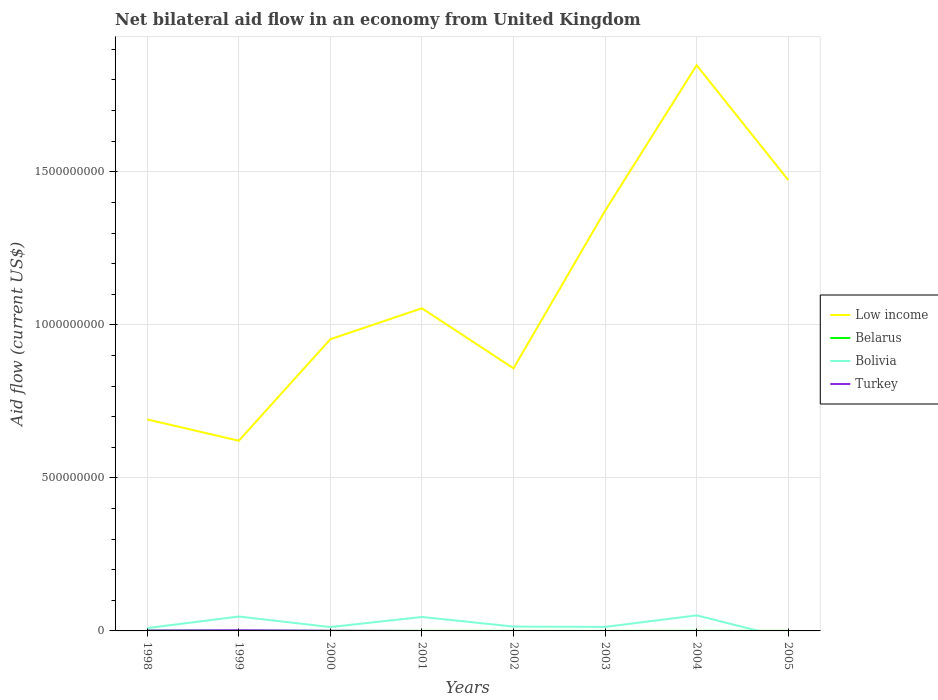Is the number of lines equal to the number of legend labels?
Ensure brevity in your answer.  No. Across all years, what is the maximum net bilateral aid flow in Belarus?
Your answer should be very brief. 7.00e+04. What is the total net bilateral aid flow in Belarus in the graph?
Your answer should be very brief. 6.70e+05. What is the difference between the highest and the second highest net bilateral aid flow in Low income?
Offer a terse response. 1.23e+09. What is the difference between the highest and the lowest net bilateral aid flow in Bolivia?
Your answer should be compact. 3. Is the net bilateral aid flow in Bolivia strictly greater than the net bilateral aid flow in Belarus over the years?
Keep it short and to the point. No. What is the difference between two consecutive major ticks on the Y-axis?
Your answer should be very brief. 5.00e+08. Are the values on the major ticks of Y-axis written in scientific E-notation?
Offer a terse response. No. Does the graph contain any zero values?
Make the answer very short. Yes. Does the graph contain grids?
Your answer should be very brief. Yes. Where does the legend appear in the graph?
Provide a succinct answer. Center right. What is the title of the graph?
Keep it short and to the point. Net bilateral aid flow in an economy from United Kingdom. Does "Romania" appear as one of the legend labels in the graph?
Your answer should be very brief. No. What is the label or title of the X-axis?
Offer a terse response. Years. What is the Aid flow (current US$) in Low income in 1998?
Your answer should be compact. 6.91e+08. What is the Aid flow (current US$) of Bolivia in 1998?
Your response must be concise. 9.27e+06. What is the Aid flow (current US$) of Turkey in 1998?
Make the answer very short. 1.27e+06. What is the Aid flow (current US$) in Low income in 1999?
Make the answer very short. 6.21e+08. What is the Aid flow (current US$) in Belarus in 1999?
Ensure brevity in your answer.  5.80e+05. What is the Aid flow (current US$) in Bolivia in 1999?
Your answer should be compact. 4.70e+07. What is the Aid flow (current US$) of Turkey in 1999?
Offer a very short reply. 2.30e+06. What is the Aid flow (current US$) of Low income in 2000?
Make the answer very short. 9.53e+08. What is the Aid flow (current US$) of Belarus in 2000?
Offer a terse response. 2.10e+05. What is the Aid flow (current US$) in Bolivia in 2000?
Provide a short and direct response. 1.26e+07. What is the Aid flow (current US$) of Turkey in 2000?
Your response must be concise. 5.40e+05. What is the Aid flow (current US$) in Low income in 2001?
Your answer should be compact. 1.05e+09. What is the Aid flow (current US$) in Bolivia in 2001?
Make the answer very short. 4.56e+07. What is the Aid flow (current US$) in Low income in 2002?
Offer a very short reply. 8.58e+08. What is the Aid flow (current US$) in Bolivia in 2002?
Offer a terse response. 1.42e+07. What is the Aid flow (current US$) of Turkey in 2002?
Offer a terse response. 0. What is the Aid flow (current US$) of Low income in 2003?
Ensure brevity in your answer.  1.37e+09. What is the Aid flow (current US$) of Bolivia in 2003?
Make the answer very short. 1.31e+07. What is the Aid flow (current US$) in Turkey in 2003?
Make the answer very short. 0. What is the Aid flow (current US$) of Low income in 2004?
Ensure brevity in your answer.  1.85e+09. What is the Aid flow (current US$) in Bolivia in 2004?
Offer a terse response. 5.08e+07. What is the Aid flow (current US$) of Low income in 2005?
Your answer should be very brief. 1.47e+09. What is the Aid flow (current US$) of Belarus in 2005?
Give a very brief answer. 1.10e+05. What is the Aid flow (current US$) in Bolivia in 2005?
Your response must be concise. 0. Across all years, what is the maximum Aid flow (current US$) in Low income?
Ensure brevity in your answer.  1.85e+09. Across all years, what is the maximum Aid flow (current US$) of Bolivia?
Give a very brief answer. 5.08e+07. Across all years, what is the maximum Aid flow (current US$) of Turkey?
Provide a succinct answer. 2.30e+06. Across all years, what is the minimum Aid flow (current US$) in Low income?
Offer a very short reply. 6.21e+08. Across all years, what is the minimum Aid flow (current US$) in Belarus?
Keep it short and to the point. 7.00e+04. Across all years, what is the minimum Aid flow (current US$) of Bolivia?
Offer a very short reply. 0. Across all years, what is the minimum Aid flow (current US$) in Turkey?
Offer a very short reply. 0. What is the total Aid flow (current US$) of Low income in the graph?
Offer a terse response. 8.87e+09. What is the total Aid flow (current US$) in Belarus in the graph?
Offer a very short reply. 2.19e+06. What is the total Aid flow (current US$) in Bolivia in the graph?
Offer a terse response. 1.93e+08. What is the total Aid flow (current US$) of Turkey in the graph?
Make the answer very short. 4.11e+06. What is the difference between the Aid flow (current US$) of Low income in 1998 and that in 1999?
Make the answer very short. 6.96e+07. What is the difference between the Aid flow (current US$) in Bolivia in 1998 and that in 1999?
Your response must be concise. -3.78e+07. What is the difference between the Aid flow (current US$) of Turkey in 1998 and that in 1999?
Give a very brief answer. -1.03e+06. What is the difference between the Aid flow (current US$) of Low income in 1998 and that in 2000?
Offer a very short reply. -2.62e+08. What is the difference between the Aid flow (current US$) in Belarus in 1998 and that in 2000?
Ensure brevity in your answer.  5.90e+05. What is the difference between the Aid flow (current US$) in Bolivia in 1998 and that in 2000?
Provide a succinct answer. -3.32e+06. What is the difference between the Aid flow (current US$) of Turkey in 1998 and that in 2000?
Your answer should be compact. 7.30e+05. What is the difference between the Aid flow (current US$) of Low income in 1998 and that in 2001?
Your answer should be very brief. -3.63e+08. What is the difference between the Aid flow (current US$) of Belarus in 1998 and that in 2001?
Provide a succinct answer. 6.70e+05. What is the difference between the Aid flow (current US$) in Bolivia in 1998 and that in 2001?
Your response must be concise. -3.63e+07. What is the difference between the Aid flow (current US$) in Low income in 1998 and that in 2002?
Your answer should be very brief. -1.67e+08. What is the difference between the Aid flow (current US$) in Belarus in 1998 and that in 2002?
Ensure brevity in your answer.  7.10e+05. What is the difference between the Aid flow (current US$) of Bolivia in 1998 and that in 2002?
Provide a succinct answer. -4.92e+06. What is the difference between the Aid flow (current US$) of Low income in 1998 and that in 2003?
Offer a terse response. -6.82e+08. What is the difference between the Aid flow (current US$) in Belarus in 1998 and that in 2003?
Keep it short and to the point. 7.30e+05. What is the difference between the Aid flow (current US$) of Bolivia in 1998 and that in 2003?
Provide a short and direct response. -3.83e+06. What is the difference between the Aid flow (current US$) in Low income in 1998 and that in 2004?
Offer a terse response. -1.16e+09. What is the difference between the Aid flow (current US$) of Bolivia in 1998 and that in 2004?
Ensure brevity in your answer.  -4.16e+07. What is the difference between the Aid flow (current US$) of Low income in 1998 and that in 2005?
Provide a succinct answer. -7.82e+08. What is the difference between the Aid flow (current US$) in Belarus in 1998 and that in 2005?
Keep it short and to the point. 6.90e+05. What is the difference between the Aid flow (current US$) of Low income in 1999 and that in 2000?
Provide a succinct answer. -3.32e+08. What is the difference between the Aid flow (current US$) in Belarus in 1999 and that in 2000?
Keep it short and to the point. 3.70e+05. What is the difference between the Aid flow (current US$) of Bolivia in 1999 and that in 2000?
Give a very brief answer. 3.45e+07. What is the difference between the Aid flow (current US$) of Turkey in 1999 and that in 2000?
Make the answer very short. 1.76e+06. What is the difference between the Aid flow (current US$) in Low income in 1999 and that in 2001?
Ensure brevity in your answer.  -4.33e+08. What is the difference between the Aid flow (current US$) in Belarus in 1999 and that in 2001?
Provide a succinct answer. 4.50e+05. What is the difference between the Aid flow (current US$) of Bolivia in 1999 and that in 2001?
Offer a very short reply. 1.47e+06. What is the difference between the Aid flow (current US$) in Low income in 1999 and that in 2002?
Ensure brevity in your answer.  -2.37e+08. What is the difference between the Aid flow (current US$) in Belarus in 1999 and that in 2002?
Offer a terse response. 4.90e+05. What is the difference between the Aid flow (current US$) in Bolivia in 1999 and that in 2002?
Offer a terse response. 3.29e+07. What is the difference between the Aid flow (current US$) in Low income in 1999 and that in 2003?
Provide a succinct answer. -7.51e+08. What is the difference between the Aid flow (current US$) of Belarus in 1999 and that in 2003?
Ensure brevity in your answer.  5.10e+05. What is the difference between the Aid flow (current US$) of Bolivia in 1999 and that in 2003?
Your answer should be compact. 3.40e+07. What is the difference between the Aid flow (current US$) in Low income in 1999 and that in 2004?
Keep it short and to the point. -1.23e+09. What is the difference between the Aid flow (current US$) of Belarus in 1999 and that in 2004?
Offer a very short reply. 3.80e+05. What is the difference between the Aid flow (current US$) in Bolivia in 1999 and that in 2004?
Give a very brief answer. -3.78e+06. What is the difference between the Aid flow (current US$) of Low income in 1999 and that in 2005?
Your response must be concise. -8.52e+08. What is the difference between the Aid flow (current US$) in Belarus in 1999 and that in 2005?
Provide a short and direct response. 4.70e+05. What is the difference between the Aid flow (current US$) in Low income in 2000 and that in 2001?
Provide a short and direct response. -1.01e+08. What is the difference between the Aid flow (current US$) of Belarus in 2000 and that in 2001?
Make the answer very short. 8.00e+04. What is the difference between the Aid flow (current US$) of Bolivia in 2000 and that in 2001?
Make the answer very short. -3.30e+07. What is the difference between the Aid flow (current US$) in Low income in 2000 and that in 2002?
Make the answer very short. 9.52e+07. What is the difference between the Aid flow (current US$) in Bolivia in 2000 and that in 2002?
Give a very brief answer. -1.60e+06. What is the difference between the Aid flow (current US$) of Low income in 2000 and that in 2003?
Your answer should be very brief. -4.20e+08. What is the difference between the Aid flow (current US$) in Bolivia in 2000 and that in 2003?
Ensure brevity in your answer.  -5.10e+05. What is the difference between the Aid flow (current US$) in Low income in 2000 and that in 2004?
Provide a succinct answer. -8.95e+08. What is the difference between the Aid flow (current US$) in Belarus in 2000 and that in 2004?
Provide a succinct answer. 10000. What is the difference between the Aid flow (current US$) of Bolivia in 2000 and that in 2004?
Ensure brevity in your answer.  -3.82e+07. What is the difference between the Aid flow (current US$) in Low income in 2000 and that in 2005?
Provide a succinct answer. -5.20e+08. What is the difference between the Aid flow (current US$) of Belarus in 2000 and that in 2005?
Provide a short and direct response. 1.00e+05. What is the difference between the Aid flow (current US$) in Low income in 2001 and that in 2002?
Your answer should be compact. 1.96e+08. What is the difference between the Aid flow (current US$) of Bolivia in 2001 and that in 2002?
Give a very brief answer. 3.14e+07. What is the difference between the Aid flow (current US$) in Low income in 2001 and that in 2003?
Provide a short and direct response. -3.19e+08. What is the difference between the Aid flow (current US$) in Belarus in 2001 and that in 2003?
Give a very brief answer. 6.00e+04. What is the difference between the Aid flow (current US$) in Bolivia in 2001 and that in 2003?
Your response must be concise. 3.25e+07. What is the difference between the Aid flow (current US$) of Low income in 2001 and that in 2004?
Offer a very short reply. -7.94e+08. What is the difference between the Aid flow (current US$) in Bolivia in 2001 and that in 2004?
Offer a terse response. -5.25e+06. What is the difference between the Aid flow (current US$) in Low income in 2001 and that in 2005?
Keep it short and to the point. -4.19e+08. What is the difference between the Aid flow (current US$) in Low income in 2002 and that in 2003?
Keep it short and to the point. -5.15e+08. What is the difference between the Aid flow (current US$) in Belarus in 2002 and that in 2003?
Ensure brevity in your answer.  2.00e+04. What is the difference between the Aid flow (current US$) of Bolivia in 2002 and that in 2003?
Keep it short and to the point. 1.09e+06. What is the difference between the Aid flow (current US$) of Low income in 2002 and that in 2004?
Make the answer very short. -9.90e+08. What is the difference between the Aid flow (current US$) of Bolivia in 2002 and that in 2004?
Your answer should be compact. -3.66e+07. What is the difference between the Aid flow (current US$) in Low income in 2002 and that in 2005?
Your answer should be compact. -6.15e+08. What is the difference between the Aid flow (current US$) in Belarus in 2002 and that in 2005?
Provide a short and direct response. -2.00e+04. What is the difference between the Aid flow (current US$) in Low income in 2003 and that in 2004?
Provide a short and direct response. -4.76e+08. What is the difference between the Aid flow (current US$) of Bolivia in 2003 and that in 2004?
Keep it short and to the point. -3.77e+07. What is the difference between the Aid flow (current US$) of Low income in 2003 and that in 2005?
Keep it short and to the point. -1.01e+08. What is the difference between the Aid flow (current US$) in Low income in 2004 and that in 2005?
Your response must be concise. 3.75e+08. What is the difference between the Aid flow (current US$) of Low income in 1998 and the Aid flow (current US$) of Belarus in 1999?
Your answer should be very brief. 6.90e+08. What is the difference between the Aid flow (current US$) in Low income in 1998 and the Aid flow (current US$) in Bolivia in 1999?
Offer a very short reply. 6.44e+08. What is the difference between the Aid flow (current US$) of Low income in 1998 and the Aid flow (current US$) of Turkey in 1999?
Provide a succinct answer. 6.89e+08. What is the difference between the Aid flow (current US$) in Belarus in 1998 and the Aid flow (current US$) in Bolivia in 1999?
Keep it short and to the point. -4.62e+07. What is the difference between the Aid flow (current US$) of Belarus in 1998 and the Aid flow (current US$) of Turkey in 1999?
Give a very brief answer. -1.50e+06. What is the difference between the Aid flow (current US$) of Bolivia in 1998 and the Aid flow (current US$) of Turkey in 1999?
Your response must be concise. 6.97e+06. What is the difference between the Aid flow (current US$) in Low income in 1998 and the Aid flow (current US$) in Belarus in 2000?
Your response must be concise. 6.91e+08. What is the difference between the Aid flow (current US$) of Low income in 1998 and the Aid flow (current US$) of Bolivia in 2000?
Your response must be concise. 6.78e+08. What is the difference between the Aid flow (current US$) of Low income in 1998 and the Aid flow (current US$) of Turkey in 2000?
Ensure brevity in your answer.  6.90e+08. What is the difference between the Aid flow (current US$) in Belarus in 1998 and the Aid flow (current US$) in Bolivia in 2000?
Your answer should be very brief. -1.18e+07. What is the difference between the Aid flow (current US$) in Belarus in 1998 and the Aid flow (current US$) in Turkey in 2000?
Make the answer very short. 2.60e+05. What is the difference between the Aid flow (current US$) of Bolivia in 1998 and the Aid flow (current US$) of Turkey in 2000?
Your answer should be compact. 8.73e+06. What is the difference between the Aid flow (current US$) in Low income in 1998 and the Aid flow (current US$) in Belarus in 2001?
Offer a terse response. 6.91e+08. What is the difference between the Aid flow (current US$) of Low income in 1998 and the Aid flow (current US$) of Bolivia in 2001?
Your answer should be compact. 6.45e+08. What is the difference between the Aid flow (current US$) of Belarus in 1998 and the Aid flow (current US$) of Bolivia in 2001?
Offer a terse response. -4.48e+07. What is the difference between the Aid flow (current US$) of Low income in 1998 and the Aid flow (current US$) of Belarus in 2002?
Provide a succinct answer. 6.91e+08. What is the difference between the Aid flow (current US$) in Low income in 1998 and the Aid flow (current US$) in Bolivia in 2002?
Your answer should be compact. 6.77e+08. What is the difference between the Aid flow (current US$) of Belarus in 1998 and the Aid flow (current US$) of Bolivia in 2002?
Your answer should be compact. -1.34e+07. What is the difference between the Aid flow (current US$) in Low income in 1998 and the Aid flow (current US$) in Belarus in 2003?
Ensure brevity in your answer.  6.91e+08. What is the difference between the Aid flow (current US$) of Low income in 1998 and the Aid flow (current US$) of Bolivia in 2003?
Offer a terse response. 6.78e+08. What is the difference between the Aid flow (current US$) of Belarus in 1998 and the Aid flow (current US$) of Bolivia in 2003?
Offer a terse response. -1.23e+07. What is the difference between the Aid flow (current US$) of Low income in 1998 and the Aid flow (current US$) of Belarus in 2004?
Your answer should be very brief. 6.91e+08. What is the difference between the Aid flow (current US$) of Low income in 1998 and the Aid flow (current US$) of Bolivia in 2004?
Your response must be concise. 6.40e+08. What is the difference between the Aid flow (current US$) of Belarus in 1998 and the Aid flow (current US$) of Bolivia in 2004?
Your answer should be compact. -5.00e+07. What is the difference between the Aid flow (current US$) of Low income in 1998 and the Aid flow (current US$) of Belarus in 2005?
Provide a succinct answer. 6.91e+08. What is the difference between the Aid flow (current US$) in Low income in 1999 and the Aid flow (current US$) in Belarus in 2000?
Ensure brevity in your answer.  6.21e+08. What is the difference between the Aid flow (current US$) of Low income in 1999 and the Aid flow (current US$) of Bolivia in 2000?
Offer a very short reply. 6.09e+08. What is the difference between the Aid flow (current US$) of Low income in 1999 and the Aid flow (current US$) of Turkey in 2000?
Keep it short and to the point. 6.21e+08. What is the difference between the Aid flow (current US$) in Belarus in 1999 and the Aid flow (current US$) in Bolivia in 2000?
Keep it short and to the point. -1.20e+07. What is the difference between the Aid flow (current US$) of Belarus in 1999 and the Aid flow (current US$) of Turkey in 2000?
Your answer should be very brief. 4.00e+04. What is the difference between the Aid flow (current US$) in Bolivia in 1999 and the Aid flow (current US$) in Turkey in 2000?
Provide a short and direct response. 4.65e+07. What is the difference between the Aid flow (current US$) in Low income in 1999 and the Aid flow (current US$) in Belarus in 2001?
Ensure brevity in your answer.  6.21e+08. What is the difference between the Aid flow (current US$) in Low income in 1999 and the Aid flow (current US$) in Bolivia in 2001?
Offer a very short reply. 5.76e+08. What is the difference between the Aid flow (current US$) of Belarus in 1999 and the Aid flow (current US$) of Bolivia in 2001?
Give a very brief answer. -4.50e+07. What is the difference between the Aid flow (current US$) in Low income in 1999 and the Aid flow (current US$) in Belarus in 2002?
Keep it short and to the point. 6.21e+08. What is the difference between the Aid flow (current US$) in Low income in 1999 and the Aid flow (current US$) in Bolivia in 2002?
Your response must be concise. 6.07e+08. What is the difference between the Aid flow (current US$) of Belarus in 1999 and the Aid flow (current US$) of Bolivia in 2002?
Make the answer very short. -1.36e+07. What is the difference between the Aid flow (current US$) of Low income in 1999 and the Aid flow (current US$) of Belarus in 2003?
Make the answer very short. 6.21e+08. What is the difference between the Aid flow (current US$) in Low income in 1999 and the Aid flow (current US$) in Bolivia in 2003?
Give a very brief answer. 6.08e+08. What is the difference between the Aid flow (current US$) in Belarus in 1999 and the Aid flow (current US$) in Bolivia in 2003?
Ensure brevity in your answer.  -1.25e+07. What is the difference between the Aid flow (current US$) of Low income in 1999 and the Aid flow (current US$) of Belarus in 2004?
Keep it short and to the point. 6.21e+08. What is the difference between the Aid flow (current US$) of Low income in 1999 and the Aid flow (current US$) of Bolivia in 2004?
Your answer should be very brief. 5.71e+08. What is the difference between the Aid flow (current US$) in Belarus in 1999 and the Aid flow (current US$) in Bolivia in 2004?
Offer a terse response. -5.02e+07. What is the difference between the Aid flow (current US$) in Low income in 1999 and the Aid flow (current US$) in Belarus in 2005?
Make the answer very short. 6.21e+08. What is the difference between the Aid flow (current US$) in Low income in 2000 and the Aid flow (current US$) in Belarus in 2001?
Give a very brief answer. 9.53e+08. What is the difference between the Aid flow (current US$) of Low income in 2000 and the Aid flow (current US$) of Bolivia in 2001?
Your answer should be compact. 9.08e+08. What is the difference between the Aid flow (current US$) in Belarus in 2000 and the Aid flow (current US$) in Bolivia in 2001?
Offer a very short reply. -4.54e+07. What is the difference between the Aid flow (current US$) of Low income in 2000 and the Aid flow (current US$) of Belarus in 2002?
Provide a short and direct response. 9.53e+08. What is the difference between the Aid flow (current US$) in Low income in 2000 and the Aid flow (current US$) in Bolivia in 2002?
Keep it short and to the point. 9.39e+08. What is the difference between the Aid flow (current US$) in Belarus in 2000 and the Aid flow (current US$) in Bolivia in 2002?
Your answer should be compact. -1.40e+07. What is the difference between the Aid flow (current US$) in Low income in 2000 and the Aid flow (current US$) in Belarus in 2003?
Make the answer very short. 9.53e+08. What is the difference between the Aid flow (current US$) in Low income in 2000 and the Aid flow (current US$) in Bolivia in 2003?
Make the answer very short. 9.40e+08. What is the difference between the Aid flow (current US$) in Belarus in 2000 and the Aid flow (current US$) in Bolivia in 2003?
Give a very brief answer. -1.29e+07. What is the difference between the Aid flow (current US$) of Low income in 2000 and the Aid flow (current US$) of Belarus in 2004?
Provide a short and direct response. 9.53e+08. What is the difference between the Aid flow (current US$) in Low income in 2000 and the Aid flow (current US$) in Bolivia in 2004?
Your response must be concise. 9.02e+08. What is the difference between the Aid flow (current US$) of Belarus in 2000 and the Aid flow (current US$) of Bolivia in 2004?
Provide a succinct answer. -5.06e+07. What is the difference between the Aid flow (current US$) of Low income in 2000 and the Aid flow (current US$) of Belarus in 2005?
Give a very brief answer. 9.53e+08. What is the difference between the Aid flow (current US$) in Low income in 2001 and the Aid flow (current US$) in Belarus in 2002?
Your answer should be very brief. 1.05e+09. What is the difference between the Aid flow (current US$) in Low income in 2001 and the Aid flow (current US$) in Bolivia in 2002?
Make the answer very short. 1.04e+09. What is the difference between the Aid flow (current US$) of Belarus in 2001 and the Aid flow (current US$) of Bolivia in 2002?
Your response must be concise. -1.41e+07. What is the difference between the Aid flow (current US$) in Low income in 2001 and the Aid flow (current US$) in Belarus in 2003?
Provide a short and direct response. 1.05e+09. What is the difference between the Aid flow (current US$) of Low income in 2001 and the Aid flow (current US$) of Bolivia in 2003?
Your answer should be compact. 1.04e+09. What is the difference between the Aid flow (current US$) in Belarus in 2001 and the Aid flow (current US$) in Bolivia in 2003?
Offer a terse response. -1.30e+07. What is the difference between the Aid flow (current US$) of Low income in 2001 and the Aid flow (current US$) of Belarus in 2004?
Your answer should be very brief. 1.05e+09. What is the difference between the Aid flow (current US$) in Low income in 2001 and the Aid flow (current US$) in Bolivia in 2004?
Offer a very short reply. 1.00e+09. What is the difference between the Aid flow (current US$) in Belarus in 2001 and the Aid flow (current US$) in Bolivia in 2004?
Ensure brevity in your answer.  -5.07e+07. What is the difference between the Aid flow (current US$) of Low income in 2001 and the Aid flow (current US$) of Belarus in 2005?
Your response must be concise. 1.05e+09. What is the difference between the Aid flow (current US$) in Low income in 2002 and the Aid flow (current US$) in Belarus in 2003?
Your answer should be very brief. 8.58e+08. What is the difference between the Aid flow (current US$) of Low income in 2002 and the Aid flow (current US$) of Bolivia in 2003?
Provide a short and direct response. 8.45e+08. What is the difference between the Aid flow (current US$) of Belarus in 2002 and the Aid flow (current US$) of Bolivia in 2003?
Provide a short and direct response. -1.30e+07. What is the difference between the Aid flow (current US$) of Low income in 2002 and the Aid flow (current US$) of Belarus in 2004?
Make the answer very short. 8.58e+08. What is the difference between the Aid flow (current US$) of Low income in 2002 and the Aid flow (current US$) of Bolivia in 2004?
Keep it short and to the point. 8.07e+08. What is the difference between the Aid flow (current US$) in Belarus in 2002 and the Aid flow (current US$) in Bolivia in 2004?
Ensure brevity in your answer.  -5.07e+07. What is the difference between the Aid flow (current US$) of Low income in 2002 and the Aid flow (current US$) of Belarus in 2005?
Give a very brief answer. 8.58e+08. What is the difference between the Aid flow (current US$) of Low income in 2003 and the Aid flow (current US$) of Belarus in 2004?
Ensure brevity in your answer.  1.37e+09. What is the difference between the Aid flow (current US$) of Low income in 2003 and the Aid flow (current US$) of Bolivia in 2004?
Make the answer very short. 1.32e+09. What is the difference between the Aid flow (current US$) of Belarus in 2003 and the Aid flow (current US$) of Bolivia in 2004?
Provide a short and direct response. -5.08e+07. What is the difference between the Aid flow (current US$) in Low income in 2003 and the Aid flow (current US$) in Belarus in 2005?
Give a very brief answer. 1.37e+09. What is the difference between the Aid flow (current US$) in Low income in 2004 and the Aid flow (current US$) in Belarus in 2005?
Ensure brevity in your answer.  1.85e+09. What is the average Aid flow (current US$) in Low income per year?
Keep it short and to the point. 1.11e+09. What is the average Aid flow (current US$) in Belarus per year?
Make the answer very short. 2.74e+05. What is the average Aid flow (current US$) in Bolivia per year?
Provide a short and direct response. 2.41e+07. What is the average Aid flow (current US$) of Turkey per year?
Give a very brief answer. 5.14e+05. In the year 1998, what is the difference between the Aid flow (current US$) in Low income and Aid flow (current US$) in Belarus?
Provide a short and direct response. 6.90e+08. In the year 1998, what is the difference between the Aid flow (current US$) in Low income and Aid flow (current US$) in Bolivia?
Keep it short and to the point. 6.82e+08. In the year 1998, what is the difference between the Aid flow (current US$) of Low income and Aid flow (current US$) of Turkey?
Ensure brevity in your answer.  6.90e+08. In the year 1998, what is the difference between the Aid flow (current US$) of Belarus and Aid flow (current US$) of Bolivia?
Provide a short and direct response. -8.47e+06. In the year 1998, what is the difference between the Aid flow (current US$) in Belarus and Aid flow (current US$) in Turkey?
Provide a succinct answer. -4.70e+05. In the year 1999, what is the difference between the Aid flow (current US$) of Low income and Aid flow (current US$) of Belarus?
Provide a short and direct response. 6.21e+08. In the year 1999, what is the difference between the Aid flow (current US$) of Low income and Aid flow (current US$) of Bolivia?
Provide a short and direct response. 5.74e+08. In the year 1999, what is the difference between the Aid flow (current US$) in Low income and Aid flow (current US$) in Turkey?
Provide a succinct answer. 6.19e+08. In the year 1999, what is the difference between the Aid flow (current US$) of Belarus and Aid flow (current US$) of Bolivia?
Your response must be concise. -4.65e+07. In the year 1999, what is the difference between the Aid flow (current US$) in Belarus and Aid flow (current US$) in Turkey?
Ensure brevity in your answer.  -1.72e+06. In the year 1999, what is the difference between the Aid flow (current US$) in Bolivia and Aid flow (current US$) in Turkey?
Your answer should be very brief. 4.48e+07. In the year 2000, what is the difference between the Aid flow (current US$) of Low income and Aid flow (current US$) of Belarus?
Your answer should be very brief. 9.53e+08. In the year 2000, what is the difference between the Aid flow (current US$) in Low income and Aid flow (current US$) in Bolivia?
Give a very brief answer. 9.40e+08. In the year 2000, what is the difference between the Aid flow (current US$) in Low income and Aid flow (current US$) in Turkey?
Provide a succinct answer. 9.53e+08. In the year 2000, what is the difference between the Aid flow (current US$) of Belarus and Aid flow (current US$) of Bolivia?
Make the answer very short. -1.24e+07. In the year 2000, what is the difference between the Aid flow (current US$) of Belarus and Aid flow (current US$) of Turkey?
Make the answer very short. -3.30e+05. In the year 2000, what is the difference between the Aid flow (current US$) of Bolivia and Aid flow (current US$) of Turkey?
Your response must be concise. 1.20e+07. In the year 2001, what is the difference between the Aid flow (current US$) of Low income and Aid flow (current US$) of Belarus?
Provide a short and direct response. 1.05e+09. In the year 2001, what is the difference between the Aid flow (current US$) in Low income and Aid flow (current US$) in Bolivia?
Offer a terse response. 1.01e+09. In the year 2001, what is the difference between the Aid flow (current US$) in Belarus and Aid flow (current US$) in Bolivia?
Keep it short and to the point. -4.54e+07. In the year 2002, what is the difference between the Aid flow (current US$) in Low income and Aid flow (current US$) in Belarus?
Provide a succinct answer. 8.58e+08. In the year 2002, what is the difference between the Aid flow (current US$) in Low income and Aid flow (current US$) in Bolivia?
Your answer should be compact. 8.44e+08. In the year 2002, what is the difference between the Aid flow (current US$) of Belarus and Aid flow (current US$) of Bolivia?
Offer a very short reply. -1.41e+07. In the year 2003, what is the difference between the Aid flow (current US$) of Low income and Aid flow (current US$) of Belarus?
Offer a terse response. 1.37e+09. In the year 2003, what is the difference between the Aid flow (current US$) in Low income and Aid flow (current US$) in Bolivia?
Keep it short and to the point. 1.36e+09. In the year 2003, what is the difference between the Aid flow (current US$) in Belarus and Aid flow (current US$) in Bolivia?
Provide a short and direct response. -1.30e+07. In the year 2004, what is the difference between the Aid flow (current US$) in Low income and Aid flow (current US$) in Belarus?
Your answer should be compact. 1.85e+09. In the year 2004, what is the difference between the Aid flow (current US$) in Low income and Aid flow (current US$) in Bolivia?
Provide a short and direct response. 1.80e+09. In the year 2004, what is the difference between the Aid flow (current US$) of Belarus and Aid flow (current US$) of Bolivia?
Offer a terse response. -5.06e+07. In the year 2005, what is the difference between the Aid flow (current US$) of Low income and Aid flow (current US$) of Belarus?
Your answer should be compact. 1.47e+09. What is the ratio of the Aid flow (current US$) in Low income in 1998 to that in 1999?
Provide a short and direct response. 1.11. What is the ratio of the Aid flow (current US$) of Belarus in 1998 to that in 1999?
Make the answer very short. 1.38. What is the ratio of the Aid flow (current US$) in Bolivia in 1998 to that in 1999?
Your answer should be compact. 0.2. What is the ratio of the Aid flow (current US$) in Turkey in 1998 to that in 1999?
Ensure brevity in your answer.  0.55. What is the ratio of the Aid flow (current US$) of Low income in 1998 to that in 2000?
Your response must be concise. 0.72. What is the ratio of the Aid flow (current US$) in Belarus in 1998 to that in 2000?
Offer a very short reply. 3.81. What is the ratio of the Aid flow (current US$) of Bolivia in 1998 to that in 2000?
Keep it short and to the point. 0.74. What is the ratio of the Aid flow (current US$) of Turkey in 1998 to that in 2000?
Ensure brevity in your answer.  2.35. What is the ratio of the Aid flow (current US$) of Low income in 1998 to that in 2001?
Provide a succinct answer. 0.66. What is the ratio of the Aid flow (current US$) of Belarus in 1998 to that in 2001?
Give a very brief answer. 6.15. What is the ratio of the Aid flow (current US$) in Bolivia in 1998 to that in 2001?
Your answer should be very brief. 0.2. What is the ratio of the Aid flow (current US$) in Low income in 1998 to that in 2002?
Your answer should be very brief. 0.81. What is the ratio of the Aid flow (current US$) of Belarus in 1998 to that in 2002?
Make the answer very short. 8.89. What is the ratio of the Aid flow (current US$) of Bolivia in 1998 to that in 2002?
Provide a succinct answer. 0.65. What is the ratio of the Aid flow (current US$) in Low income in 1998 to that in 2003?
Provide a short and direct response. 0.5. What is the ratio of the Aid flow (current US$) in Belarus in 1998 to that in 2003?
Offer a terse response. 11.43. What is the ratio of the Aid flow (current US$) in Bolivia in 1998 to that in 2003?
Keep it short and to the point. 0.71. What is the ratio of the Aid flow (current US$) of Low income in 1998 to that in 2004?
Your response must be concise. 0.37. What is the ratio of the Aid flow (current US$) in Bolivia in 1998 to that in 2004?
Your answer should be compact. 0.18. What is the ratio of the Aid flow (current US$) of Low income in 1998 to that in 2005?
Provide a succinct answer. 0.47. What is the ratio of the Aid flow (current US$) of Belarus in 1998 to that in 2005?
Offer a very short reply. 7.27. What is the ratio of the Aid flow (current US$) of Low income in 1999 to that in 2000?
Your answer should be compact. 0.65. What is the ratio of the Aid flow (current US$) of Belarus in 1999 to that in 2000?
Your answer should be compact. 2.76. What is the ratio of the Aid flow (current US$) of Bolivia in 1999 to that in 2000?
Keep it short and to the point. 3.74. What is the ratio of the Aid flow (current US$) in Turkey in 1999 to that in 2000?
Give a very brief answer. 4.26. What is the ratio of the Aid flow (current US$) in Low income in 1999 to that in 2001?
Give a very brief answer. 0.59. What is the ratio of the Aid flow (current US$) of Belarus in 1999 to that in 2001?
Give a very brief answer. 4.46. What is the ratio of the Aid flow (current US$) of Bolivia in 1999 to that in 2001?
Provide a short and direct response. 1.03. What is the ratio of the Aid flow (current US$) of Low income in 1999 to that in 2002?
Your response must be concise. 0.72. What is the ratio of the Aid flow (current US$) in Belarus in 1999 to that in 2002?
Your answer should be compact. 6.44. What is the ratio of the Aid flow (current US$) in Bolivia in 1999 to that in 2002?
Provide a succinct answer. 3.32. What is the ratio of the Aid flow (current US$) of Low income in 1999 to that in 2003?
Offer a very short reply. 0.45. What is the ratio of the Aid flow (current US$) of Belarus in 1999 to that in 2003?
Your response must be concise. 8.29. What is the ratio of the Aid flow (current US$) in Bolivia in 1999 to that in 2003?
Provide a short and direct response. 3.59. What is the ratio of the Aid flow (current US$) in Low income in 1999 to that in 2004?
Ensure brevity in your answer.  0.34. What is the ratio of the Aid flow (current US$) of Bolivia in 1999 to that in 2004?
Your answer should be compact. 0.93. What is the ratio of the Aid flow (current US$) in Low income in 1999 to that in 2005?
Your answer should be compact. 0.42. What is the ratio of the Aid flow (current US$) in Belarus in 1999 to that in 2005?
Your response must be concise. 5.27. What is the ratio of the Aid flow (current US$) in Low income in 2000 to that in 2001?
Your response must be concise. 0.9. What is the ratio of the Aid flow (current US$) in Belarus in 2000 to that in 2001?
Provide a short and direct response. 1.62. What is the ratio of the Aid flow (current US$) of Bolivia in 2000 to that in 2001?
Your answer should be compact. 0.28. What is the ratio of the Aid flow (current US$) in Low income in 2000 to that in 2002?
Your answer should be very brief. 1.11. What is the ratio of the Aid flow (current US$) in Belarus in 2000 to that in 2002?
Make the answer very short. 2.33. What is the ratio of the Aid flow (current US$) in Bolivia in 2000 to that in 2002?
Make the answer very short. 0.89. What is the ratio of the Aid flow (current US$) in Low income in 2000 to that in 2003?
Ensure brevity in your answer.  0.69. What is the ratio of the Aid flow (current US$) of Belarus in 2000 to that in 2003?
Ensure brevity in your answer.  3. What is the ratio of the Aid flow (current US$) in Bolivia in 2000 to that in 2003?
Your answer should be very brief. 0.96. What is the ratio of the Aid flow (current US$) of Low income in 2000 to that in 2004?
Provide a short and direct response. 0.52. What is the ratio of the Aid flow (current US$) in Bolivia in 2000 to that in 2004?
Ensure brevity in your answer.  0.25. What is the ratio of the Aid flow (current US$) of Low income in 2000 to that in 2005?
Ensure brevity in your answer.  0.65. What is the ratio of the Aid flow (current US$) in Belarus in 2000 to that in 2005?
Offer a very short reply. 1.91. What is the ratio of the Aid flow (current US$) of Low income in 2001 to that in 2002?
Your answer should be compact. 1.23. What is the ratio of the Aid flow (current US$) in Belarus in 2001 to that in 2002?
Provide a succinct answer. 1.44. What is the ratio of the Aid flow (current US$) of Bolivia in 2001 to that in 2002?
Ensure brevity in your answer.  3.21. What is the ratio of the Aid flow (current US$) of Low income in 2001 to that in 2003?
Give a very brief answer. 0.77. What is the ratio of the Aid flow (current US$) of Belarus in 2001 to that in 2003?
Provide a short and direct response. 1.86. What is the ratio of the Aid flow (current US$) in Bolivia in 2001 to that in 2003?
Your answer should be very brief. 3.48. What is the ratio of the Aid flow (current US$) in Low income in 2001 to that in 2004?
Your response must be concise. 0.57. What is the ratio of the Aid flow (current US$) in Belarus in 2001 to that in 2004?
Provide a short and direct response. 0.65. What is the ratio of the Aid flow (current US$) of Bolivia in 2001 to that in 2004?
Make the answer very short. 0.9. What is the ratio of the Aid flow (current US$) of Low income in 2001 to that in 2005?
Offer a terse response. 0.72. What is the ratio of the Aid flow (current US$) of Belarus in 2001 to that in 2005?
Make the answer very short. 1.18. What is the ratio of the Aid flow (current US$) in Low income in 2002 to that in 2003?
Your answer should be very brief. 0.62. What is the ratio of the Aid flow (current US$) in Belarus in 2002 to that in 2003?
Offer a terse response. 1.29. What is the ratio of the Aid flow (current US$) of Bolivia in 2002 to that in 2003?
Ensure brevity in your answer.  1.08. What is the ratio of the Aid flow (current US$) in Low income in 2002 to that in 2004?
Keep it short and to the point. 0.46. What is the ratio of the Aid flow (current US$) in Belarus in 2002 to that in 2004?
Provide a succinct answer. 0.45. What is the ratio of the Aid flow (current US$) in Bolivia in 2002 to that in 2004?
Offer a terse response. 0.28. What is the ratio of the Aid flow (current US$) in Low income in 2002 to that in 2005?
Give a very brief answer. 0.58. What is the ratio of the Aid flow (current US$) in Belarus in 2002 to that in 2005?
Your answer should be compact. 0.82. What is the ratio of the Aid flow (current US$) in Low income in 2003 to that in 2004?
Offer a terse response. 0.74. What is the ratio of the Aid flow (current US$) in Belarus in 2003 to that in 2004?
Keep it short and to the point. 0.35. What is the ratio of the Aid flow (current US$) in Bolivia in 2003 to that in 2004?
Your answer should be compact. 0.26. What is the ratio of the Aid flow (current US$) of Low income in 2003 to that in 2005?
Your response must be concise. 0.93. What is the ratio of the Aid flow (current US$) of Belarus in 2003 to that in 2005?
Offer a terse response. 0.64. What is the ratio of the Aid flow (current US$) in Low income in 2004 to that in 2005?
Offer a terse response. 1.25. What is the ratio of the Aid flow (current US$) in Belarus in 2004 to that in 2005?
Your answer should be compact. 1.82. What is the difference between the highest and the second highest Aid flow (current US$) in Low income?
Offer a very short reply. 3.75e+08. What is the difference between the highest and the second highest Aid flow (current US$) of Belarus?
Keep it short and to the point. 2.20e+05. What is the difference between the highest and the second highest Aid flow (current US$) in Bolivia?
Your answer should be very brief. 3.78e+06. What is the difference between the highest and the second highest Aid flow (current US$) of Turkey?
Your answer should be very brief. 1.03e+06. What is the difference between the highest and the lowest Aid flow (current US$) of Low income?
Your answer should be compact. 1.23e+09. What is the difference between the highest and the lowest Aid flow (current US$) in Belarus?
Your response must be concise. 7.30e+05. What is the difference between the highest and the lowest Aid flow (current US$) of Bolivia?
Your response must be concise. 5.08e+07. What is the difference between the highest and the lowest Aid flow (current US$) in Turkey?
Ensure brevity in your answer.  2.30e+06. 